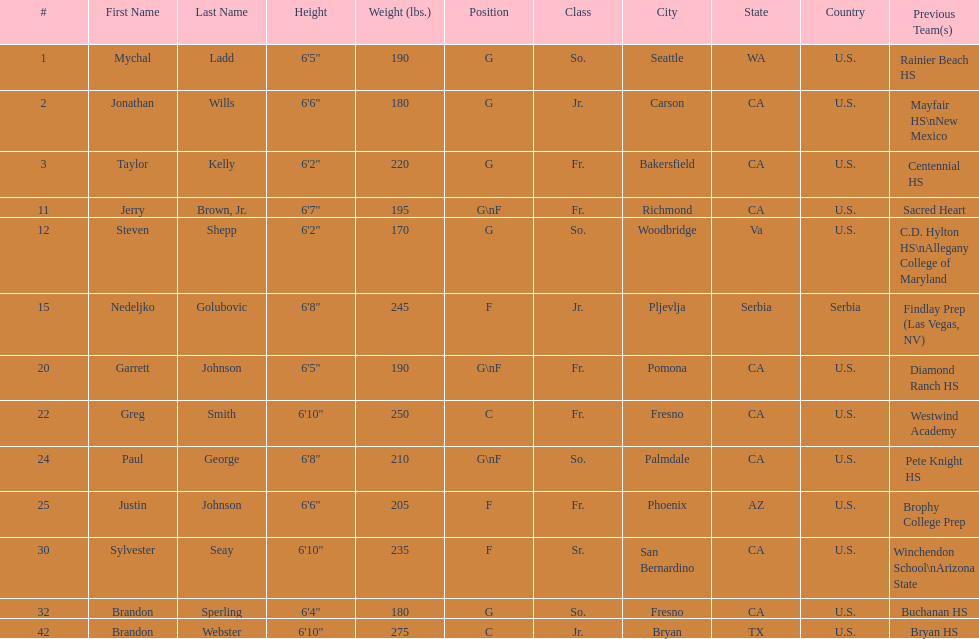Who weighs the most on the team? Brandon Webster. Could you parse the entire table? {'header': ['#', 'First Name', 'Last Name', 'Height', 'Weight (lbs.)', 'Position', 'Class', 'City', 'State', 'Country', 'Previous Team(s)'], 'rows': [['1', 'Mychal', 'Ladd', '6\'5"', '190', 'G', 'So.', 'Seattle', 'WA', 'U.S.', 'Rainier Beach HS'], ['2', 'Jonathan', 'Wills', '6\'6"', '180', 'G', 'Jr.', 'Carson', 'CA', 'U.S.', 'Mayfair HS\\nNew Mexico'], ['3', 'Taylor', 'Kelly', '6\'2"', '220', 'G', 'Fr.', 'Bakersfield', 'CA', 'U.S.', 'Centennial HS'], ['11', 'Jerry', 'Brown, Jr.', '6\'7"', '195', 'G\\nF', 'Fr.', 'Richmond', 'CA', 'U.S.', 'Sacred Heart'], ['12', 'Steven', 'Shepp', '6\'2"', '170', 'G', 'So.', 'Woodbridge', 'Va', 'U.S.', 'C.D. Hylton HS\\nAllegany College of Maryland'], ['15', 'Nedeljko', 'Golubovic', '6\'8"', '245', 'F', 'Jr.', 'Pljevlja', 'Serbia', 'Serbia', 'Findlay Prep (Las Vegas, NV)'], ['20', 'Garrett', 'Johnson', '6\'5"', '190', 'G\\nF', 'Fr.', 'Pomona', 'CA', 'U.S.', 'Diamond Ranch HS'], ['22', 'Greg', 'Smith', '6\'10"', '250', 'C', 'Fr.', 'Fresno', 'CA', 'U.S.', 'Westwind Academy'], ['24', 'Paul', 'George', '6\'8"', '210', 'G\\nF', 'So.', 'Palmdale', 'CA', 'U.S.', 'Pete Knight HS'], ['25', 'Justin', 'Johnson', '6\'6"', '205', 'F', 'Fr.', 'Phoenix', 'AZ', 'U.S.', 'Brophy College Prep'], ['30', 'Sylvester', 'Seay', '6\'10"', '235', 'F', 'Sr.', 'San Bernardino', 'CA', 'U.S.', 'Winchendon School\\nArizona State'], ['32', 'Brandon', 'Sperling', '6\'4"', '180', 'G', 'So.', 'Fresno', 'CA', 'U.S.', 'Buchanan HS'], ['42', 'Brandon', 'Webster', '6\'10"', '275', 'C', 'Jr.', 'Bryan', 'TX', 'U.S.', 'Bryan HS']]} 